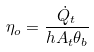<formula> <loc_0><loc_0><loc_500><loc_500>\eta _ { o } = \frac { \dot { Q } _ { t } } { h A _ { t } \theta _ { b } }</formula> 